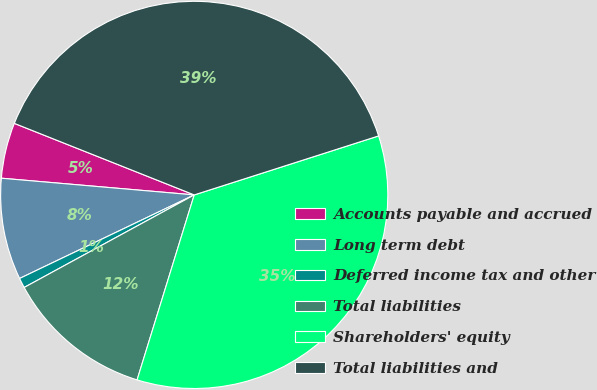Convert chart to OTSL. <chart><loc_0><loc_0><loc_500><loc_500><pie_chart><fcel>Accounts payable and accrued<fcel>Long term debt<fcel>Deferred income tax and other<fcel>Total liabilities<fcel>Shareholders' equity<fcel>Total liabilities and<nl><fcel>4.65%<fcel>8.48%<fcel>0.83%<fcel>12.3%<fcel>34.7%<fcel>39.05%<nl></chart> 